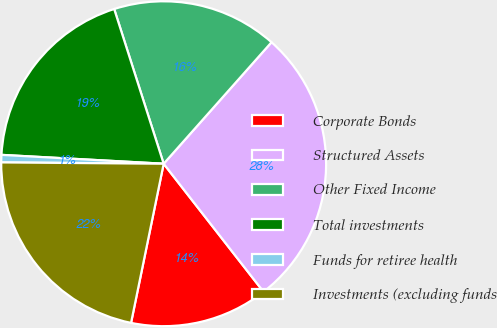Convert chart. <chart><loc_0><loc_0><loc_500><loc_500><pie_chart><fcel>Corporate Bonds<fcel>Structured Assets<fcel>Other Fixed Income<fcel>Total investments<fcel>Funds for retiree health<fcel>Investments (excluding funds<nl><fcel>13.76%<fcel>27.9%<fcel>16.48%<fcel>19.2%<fcel>0.74%<fcel>21.91%<nl></chart> 